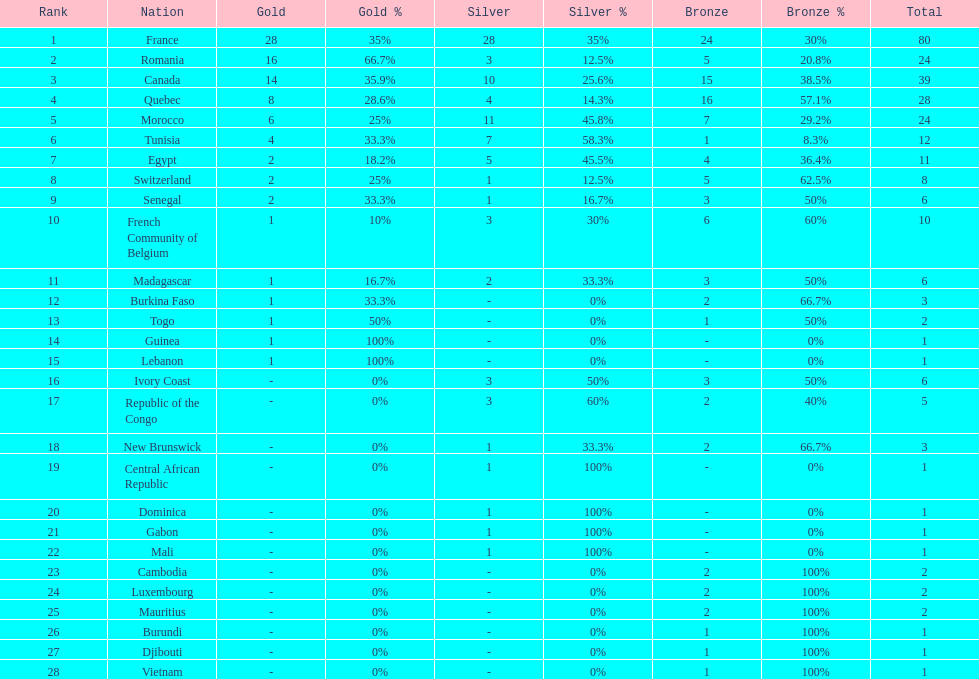How many nations won at least 10 medals? 8. Would you mind parsing the complete table? {'header': ['Rank', 'Nation', 'Gold', 'Gold %', 'Silver', 'Silver %', 'Bronze', 'Bronze %', 'Total'], 'rows': [['1', 'France', '28', '35%', '28', '35%', '24', '30%', '80'], ['2', 'Romania', '16', '66.7%', '3', '12.5%', '5', '20.8%', '24'], ['3', 'Canada', '14', '35.9%', '10', '25.6%', '15', '38.5%', '39'], ['4', 'Quebec', '8', '28.6%', '4', '14.3%', '16', '57.1%', '28'], ['5', 'Morocco', '6', '25%', '11', '45.8%', '7', '29.2%', '24'], ['6', 'Tunisia', '4', '33.3%', '7', '58.3%', '1', '8.3%', '12'], ['7', 'Egypt', '2', '18.2%', '5', '45.5%', '4', '36.4%', '11'], ['8', 'Switzerland', '2', '25%', '1', '12.5%', '5', '62.5%', '8'], ['9', 'Senegal', '2', '33.3%', '1', '16.7%', '3', '50%', '6'], ['10', 'French Community of Belgium', '1', '10%', '3', '30%', '6', '60%', '10'], ['11', 'Madagascar', '1', '16.7%', '2', '33.3%', '3', '50%', '6'], ['12', 'Burkina Faso', '1', '33.3%', '-', '0%', '2', '66.7%', '3'], ['13', 'Togo', '1', '50%', '-', '0%', '1', '50%', '2'], ['14', 'Guinea', '1', '100%', '-', '0%', '-', '0%', '1'], ['15', 'Lebanon', '1', '100%', '-', '0%', '-', '0%', '1'], ['16', 'Ivory Coast', '-', '0%', '3', '50%', '3', '50%', '6'], ['17', 'Republic of the Congo', '-', '0%', '3', '60%', '2', '40%', '5'], ['18', 'New Brunswick', '-', '0%', '1', '33.3%', '2', '66.7%', '3'], ['19', 'Central African Republic', '-', '0%', '1', '100%', '-', '0%', '1'], ['20', 'Dominica', '-', '0%', '1', '100%', '-', '0%', '1'], ['21', 'Gabon', '-', '0%', '1', '100%', '-', '0%', '1'], ['22', 'Mali', '-', '0%', '1', '100%', '-', '0%', '1'], ['23', 'Cambodia', '-', '0%', '-', '0%', '2', '100%', '2'], ['24', 'Luxembourg', '-', '0%', '-', '0%', '2', '100%', '2'], ['25', 'Mauritius', '-', '0%', '-', '0%', '2', '100%', '2'], ['26', 'Burundi', '-', '0%', '-', '0%', '1', '100%', '1'], ['27', 'Djibouti', '-', '0%', '-', '0%', '1', '100%', '1'], ['28', 'Vietnam', '-', '0%', '-', '0%', '1', '100%', '1']]} 